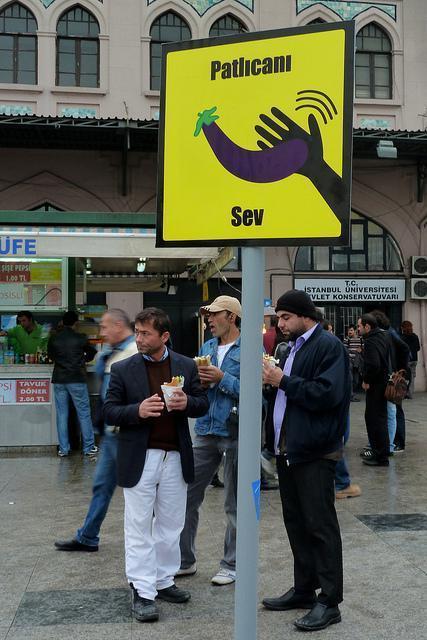How many people are in the photo?
Give a very brief answer. 6. How many chairs can you see?
Give a very brief answer. 0. 